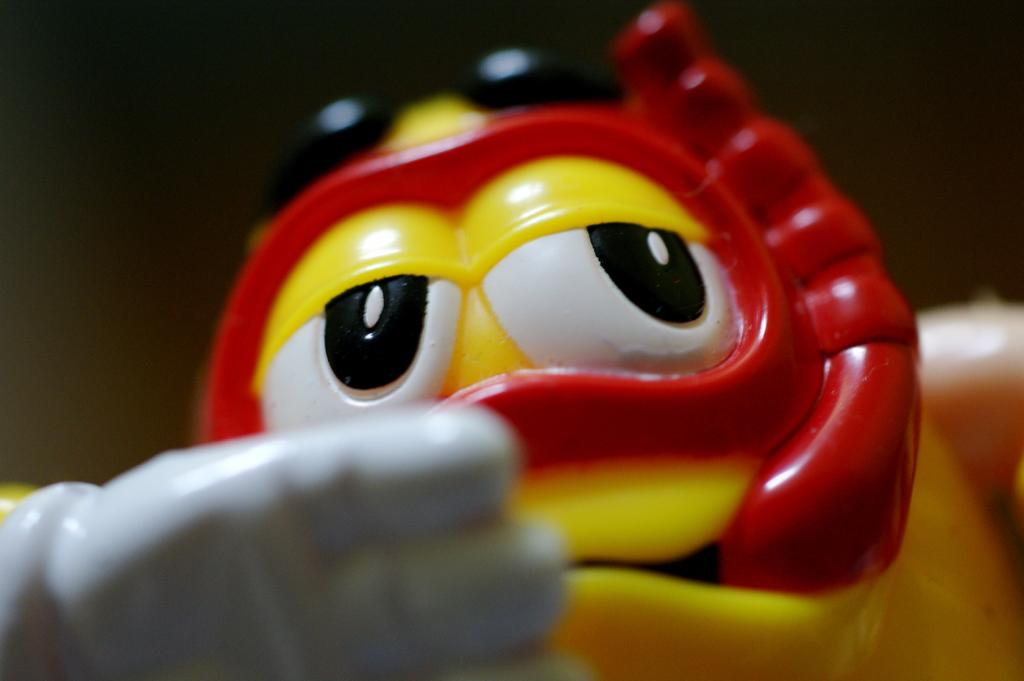What object can be seen in the image? There is a toy in the image. What can be observed about the lighting or color of the background in the image? The background of the image appears to be dark. What type of magic is being performed by the bat in the image? There is no bat or magic present in the image; it features a toy and a dark background. 